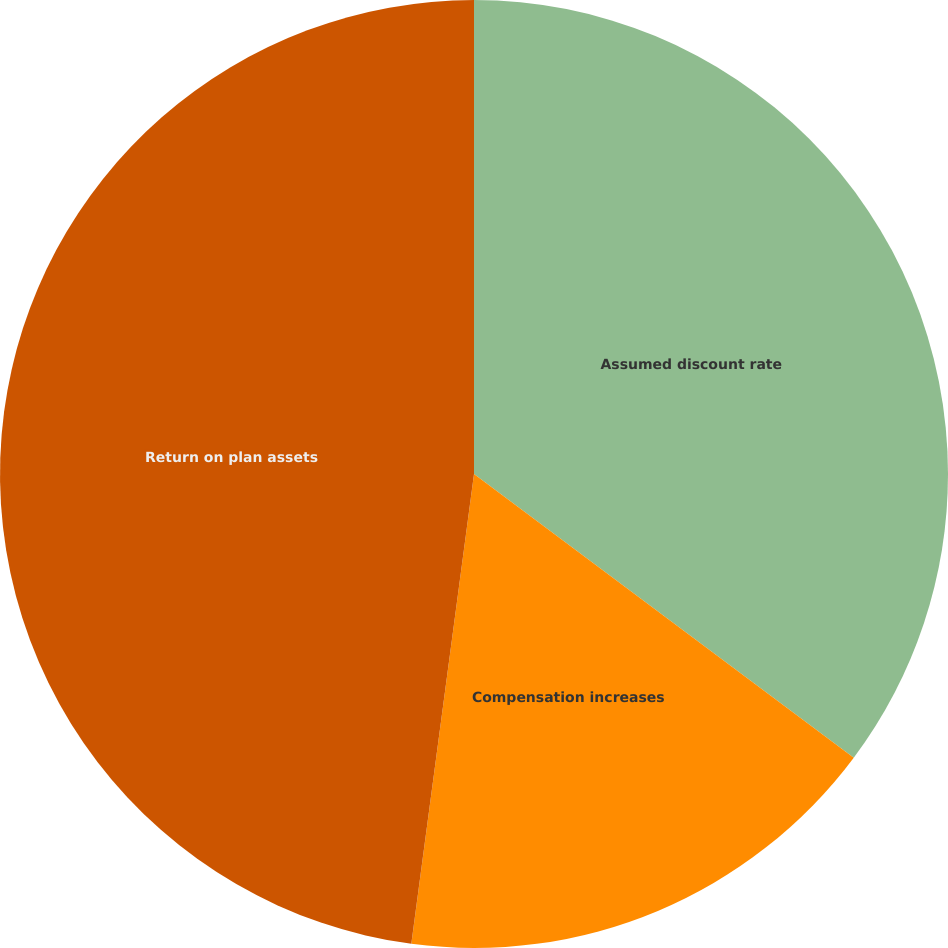<chart> <loc_0><loc_0><loc_500><loc_500><pie_chart><fcel>Assumed discount rate<fcel>Compensation increases<fcel>Return on plan assets<nl><fcel>35.21%<fcel>16.9%<fcel>47.89%<nl></chart> 